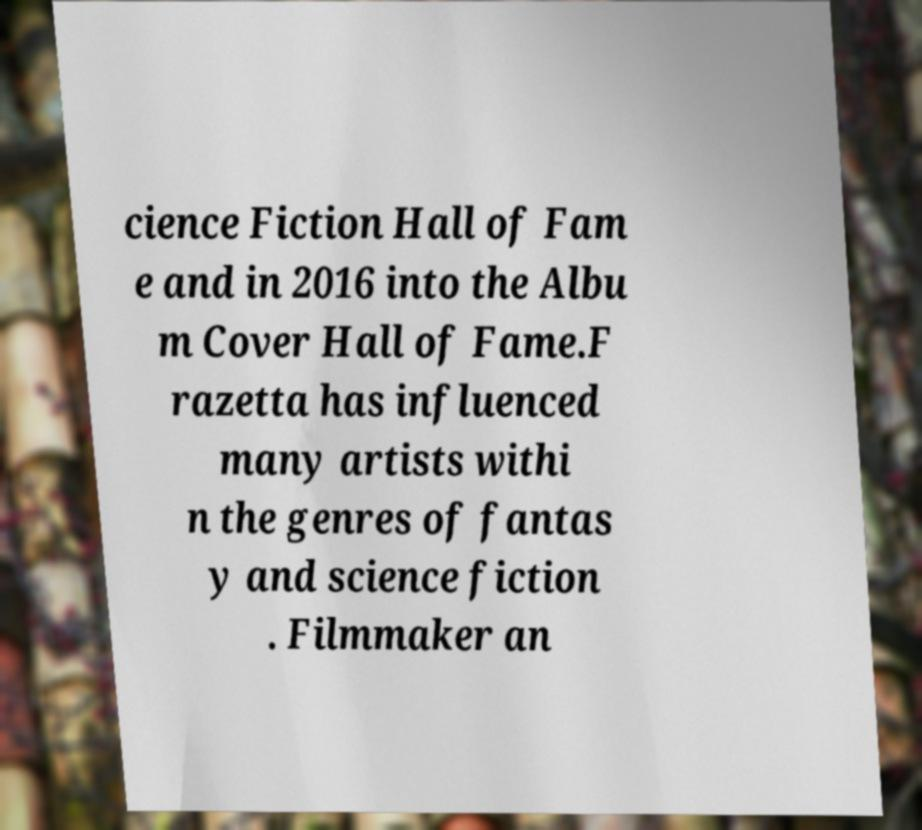Could you extract and type out the text from this image? cience Fiction Hall of Fam e and in 2016 into the Albu m Cover Hall of Fame.F razetta has influenced many artists withi n the genres of fantas y and science fiction . Filmmaker an 